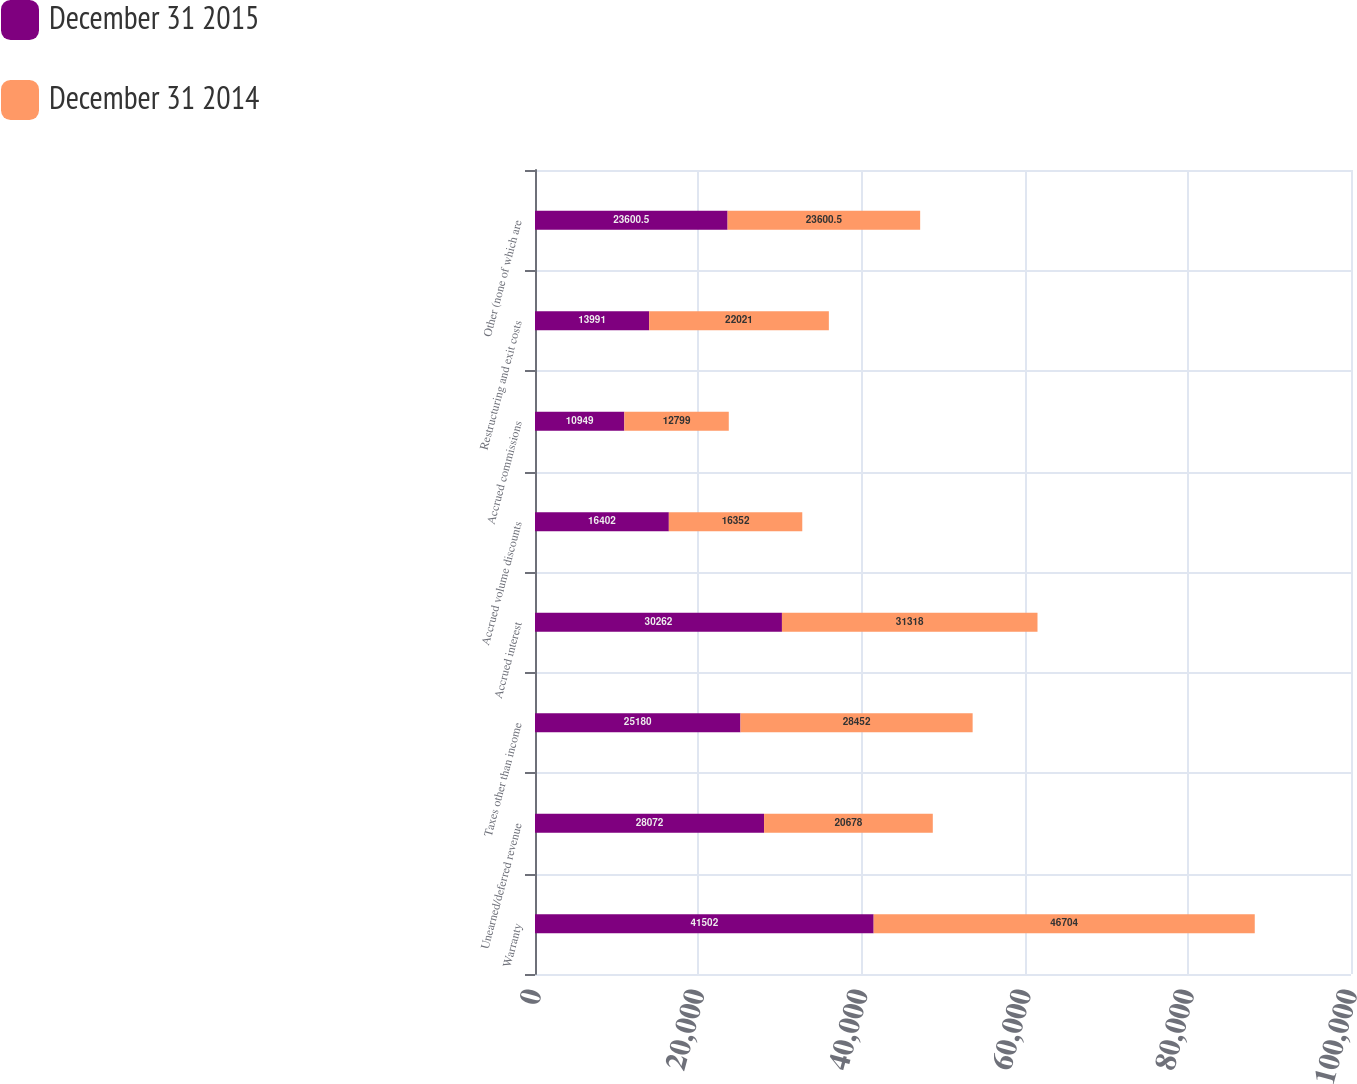<chart> <loc_0><loc_0><loc_500><loc_500><stacked_bar_chart><ecel><fcel>Warranty<fcel>Unearned/deferred revenue<fcel>Taxes other than income<fcel>Accrued interest<fcel>Accrued volume discounts<fcel>Accrued commissions<fcel>Restructuring and exit costs<fcel>Other (none of which are<nl><fcel>December 31 2015<fcel>41502<fcel>28072<fcel>25180<fcel>30262<fcel>16402<fcel>10949<fcel>13991<fcel>23600.5<nl><fcel>December 31 2014<fcel>46704<fcel>20678<fcel>28452<fcel>31318<fcel>16352<fcel>12799<fcel>22021<fcel>23600.5<nl></chart> 